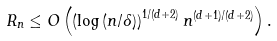Convert formula to latex. <formula><loc_0><loc_0><loc_500><loc_500>R _ { n } & \leq O \left ( \left ( \log \left ( n / \delta \right ) \right ) ^ { 1 / ( d + 2 ) } n ^ { ( d + 1 ) / ( d + 2 ) } \right ) .</formula> 